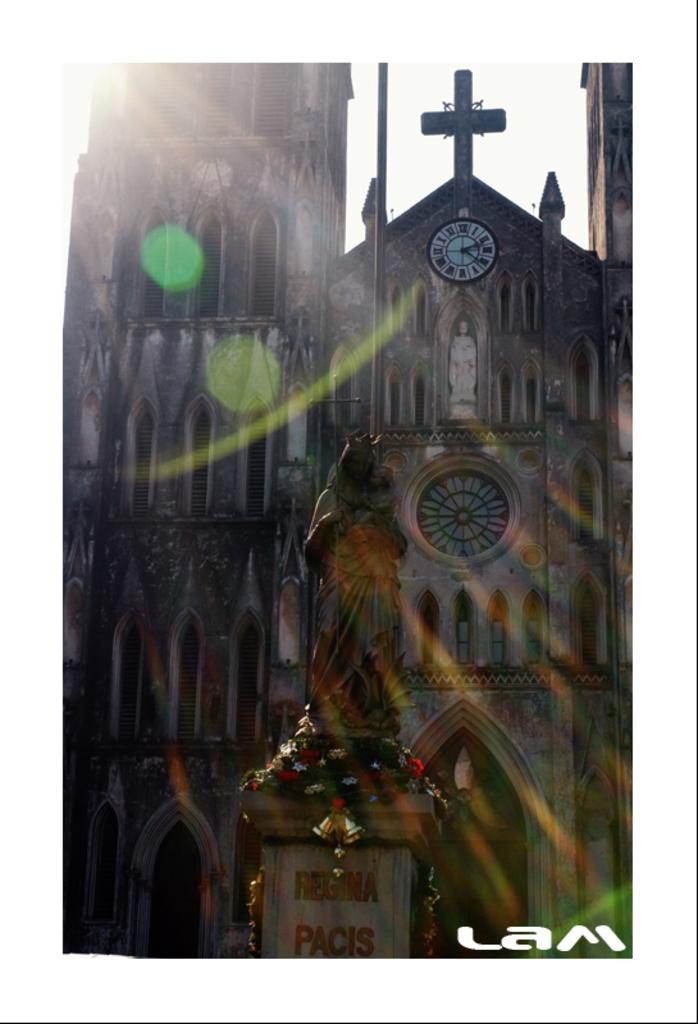What is the main subject of the image? There is a sculpture in the image. What else can be seen in the image besides the sculpture? There are decorations, a building, a clock, and text or writing in the image. Can you describe the building in the image? The building in the image is not described in the facts, so we cannot provide any details about it. What is the purpose of the clock in the image? The purpose of the clock in the image is not mentioned in the facts, so we cannot determine its purpose. What type of cloth is draped over the sculpture in the image? There is no cloth draped over the sculpture in the image. Can you describe the group of people interacting with the sculpture in the image? There is no group of people present in the image, as the facts only mention the sculpture, decorations, building, clock, and text or writing. 